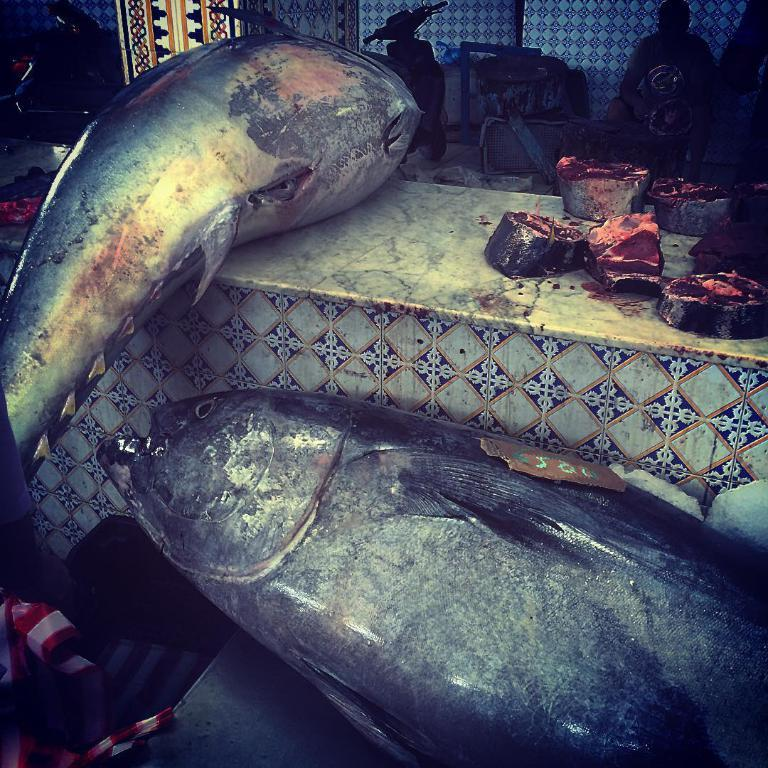What type of animal is in the image? There is a fish in the image. What else can be seen on the table in the image? There are pieces on the table. How is the fish positioned in relation to the table? The fish is kept aside. What mode of transportation is visible in the image? There is a scooter visible in the image. Who is sitting on the scooter? There is a person sitting on the scooter. What type of flower is being used to plot a scheme in the image? There is no flower or plotting of a scheme present in the image. 